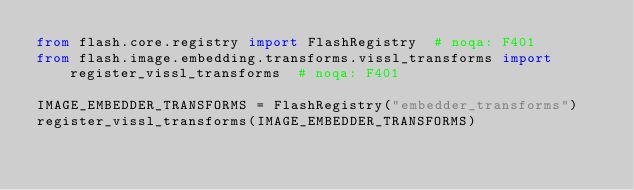Convert code to text. <code><loc_0><loc_0><loc_500><loc_500><_Python_>from flash.core.registry import FlashRegistry  # noqa: F401
from flash.image.embedding.transforms.vissl_transforms import register_vissl_transforms  # noqa: F401

IMAGE_EMBEDDER_TRANSFORMS = FlashRegistry("embedder_transforms")
register_vissl_transforms(IMAGE_EMBEDDER_TRANSFORMS)
</code> 